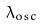<formula> <loc_0><loc_0><loc_500><loc_500>\lambda _ { o s c }</formula> 